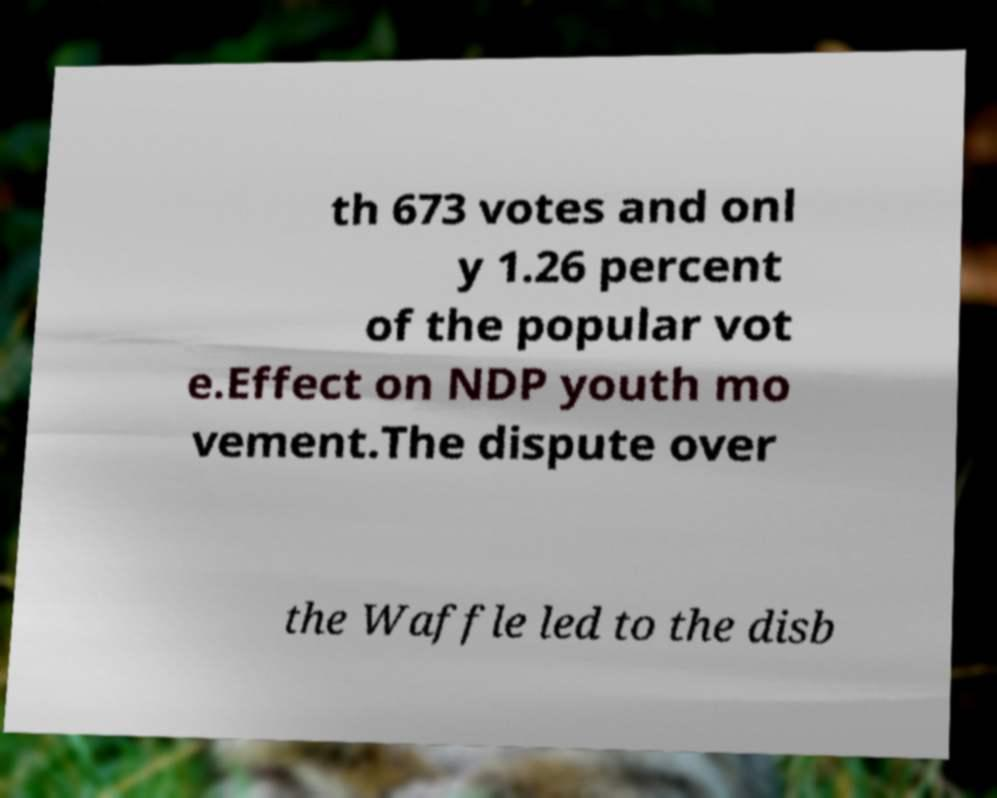Could you assist in decoding the text presented in this image and type it out clearly? th 673 votes and onl y 1.26 percent of the popular vot e.Effect on NDP youth mo vement.The dispute over the Waffle led to the disb 